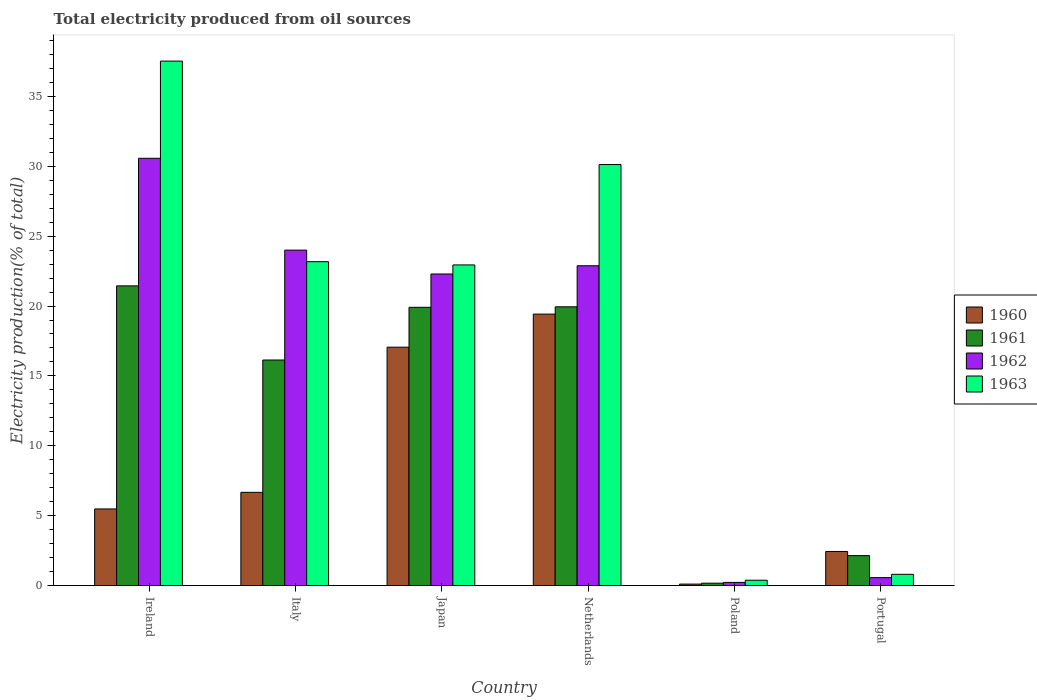Are the number of bars per tick equal to the number of legend labels?
Your response must be concise. Yes. How many bars are there on the 1st tick from the left?
Keep it short and to the point. 4. How many bars are there on the 4th tick from the right?
Ensure brevity in your answer.  4. What is the label of the 4th group of bars from the left?
Give a very brief answer. Netherlands. In how many cases, is the number of bars for a given country not equal to the number of legend labels?
Ensure brevity in your answer.  0. What is the total electricity produced in 1960 in Poland?
Offer a terse response. 0.11. Across all countries, what is the maximum total electricity produced in 1963?
Your response must be concise. 37.53. Across all countries, what is the minimum total electricity produced in 1961?
Make the answer very short. 0.17. In which country was the total electricity produced in 1961 maximum?
Your response must be concise. Ireland. In which country was the total electricity produced in 1963 minimum?
Provide a succinct answer. Poland. What is the total total electricity produced in 1963 in the graph?
Offer a very short reply. 114.95. What is the difference between the total electricity produced in 1963 in Italy and that in Portugal?
Your response must be concise. 22.37. What is the difference between the total electricity produced in 1960 in Ireland and the total electricity produced in 1961 in Italy?
Your response must be concise. -10.66. What is the average total electricity produced in 1961 per country?
Keep it short and to the point. 13.29. What is the difference between the total electricity produced of/in 1960 and total electricity produced of/in 1961 in Japan?
Ensure brevity in your answer.  -2.85. What is the ratio of the total electricity produced in 1961 in Ireland to that in Poland?
Give a very brief answer. 125.7. What is the difference between the highest and the second highest total electricity produced in 1962?
Your answer should be compact. -7.69. What is the difference between the highest and the lowest total electricity produced in 1960?
Offer a terse response. 19.32. Is it the case that in every country, the sum of the total electricity produced in 1962 and total electricity produced in 1960 is greater than the sum of total electricity produced in 1961 and total electricity produced in 1963?
Provide a succinct answer. No. What does the 2nd bar from the left in Poland represents?
Your answer should be very brief. 1961. What does the 1st bar from the right in Japan represents?
Offer a very short reply. 1963. Is it the case that in every country, the sum of the total electricity produced in 1962 and total electricity produced in 1960 is greater than the total electricity produced in 1963?
Keep it short and to the point. No. Are all the bars in the graph horizontal?
Provide a succinct answer. No. How many countries are there in the graph?
Offer a very short reply. 6. Where does the legend appear in the graph?
Offer a terse response. Center right. How are the legend labels stacked?
Your response must be concise. Vertical. What is the title of the graph?
Your response must be concise. Total electricity produced from oil sources. Does "2003" appear as one of the legend labels in the graph?
Ensure brevity in your answer.  No. What is the label or title of the X-axis?
Offer a very short reply. Country. What is the Electricity production(% of total) of 1960 in Ireland?
Make the answer very short. 5.48. What is the Electricity production(% of total) in 1961 in Ireland?
Your answer should be very brief. 21.44. What is the Electricity production(% of total) of 1962 in Ireland?
Provide a short and direct response. 30.57. What is the Electricity production(% of total) of 1963 in Ireland?
Provide a short and direct response. 37.53. What is the Electricity production(% of total) of 1960 in Italy?
Provide a succinct answer. 6.67. What is the Electricity production(% of total) in 1961 in Italy?
Ensure brevity in your answer.  16.14. What is the Electricity production(% of total) in 1962 in Italy?
Provide a succinct answer. 24. What is the Electricity production(% of total) in 1963 in Italy?
Provide a short and direct response. 23.17. What is the Electricity production(% of total) of 1960 in Japan?
Give a very brief answer. 17.06. What is the Electricity production(% of total) of 1961 in Japan?
Offer a terse response. 19.91. What is the Electricity production(% of total) of 1962 in Japan?
Give a very brief answer. 22.29. What is the Electricity production(% of total) in 1963 in Japan?
Offer a terse response. 22.94. What is the Electricity production(% of total) of 1960 in Netherlands?
Provide a short and direct response. 19.42. What is the Electricity production(% of total) of 1961 in Netherlands?
Your answer should be very brief. 19.94. What is the Electricity production(% of total) of 1962 in Netherlands?
Your answer should be very brief. 22.88. What is the Electricity production(% of total) of 1963 in Netherlands?
Provide a succinct answer. 30.12. What is the Electricity production(% of total) of 1960 in Poland?
Offer a terse response. 0.11. What is the Electricity production(% of total) in 1961 in Poland?
Offer a very short reply. 0.17. What is the Electricity production(% of total) in 1962 in Poland?
Your answer should be compact. 0.23. What is the Electricity production(% of total) of 1963 in Poland?
Your answer should be very brief. 0.38. What is the Electricity production(% of total) in 1960 in Portugal?
Give a very brief answer. 2.44. What is the Electricity production(% of total) of 1961 in Portugal?
Provide a succinct answer. 2.14. What is the Electricity production(% of total) of 1962 in Portugal?
Provide a succinct answer. 0.57. What is the Electricity production(% of total) in 1963 in Portugal?
Provide a succinct answer. 0.81. Across all countries, what is the maximum Electricity production(% of total) of 1960?
Ensure brevity in your answer.  19.42. Across all countries, what is the maximum Electricity production(% of total) in 1961?
Ensure brevity in your answer.  21.44. Across all countries, what is the maximum Electricity production(% of total) in 1962?
Give a very brief answer. 30.57. Across all countries, what is the maximum Electricity production(% of total) in 1963?
Offer a very short reply. 37.53. Across all countries, what is the minimum Electricity production(% of total) of 1960?
Make the answer very short. 0.11. Across all countries, what is the minimum Electricity production(% of total) of 1961?
Make the answer very short. 0.17. Across all countries, what is the minimum Electricity production(% of total) of 1962?
Make the answer very short. 0.23. Across all countries, what is the minimum Electricity production(% of total) of 1963?
Provide a short and direct response. 0.38. What is the total Electricity production(% of total) in 1960 in the graph?
Keep it short and to the point. 51.18. What is the total Electricity production(% of total) of 1961 in the graph?
Your response must be concise. 79.75. What is the total Electricity production(% of total) of 1962 in the graph?
Your response must be concise. 100.54. What is the total Electricity production(% of total) of 1963 in the graph?
Your answer should be compact. 114.95. What is the difference between the Electricity production(% of total) of 1960 in Ireland and that in Italy?
Offer a very short reply. -1.19. What is the difference between the Electricity production(% of total) in 1961 in Ireland and that in Italy?
Offer a very short reply. 5.3. What is the difference between the Electricity production(% of total) in 1962 in Ireland and that in Italy?
Give a very brief answer. 6.57. What is the difference between the Electricity production(% of total) in 1963 in Ireland and that in Italy?
Make the answer very short. 14.35. What is the difference between the Electricity production(% of total) in 1960 in Ireland and that in Japan?
Keep it short and to the point. -11.57. What is the difference between the Electricity production(% of total) of 1961 in Ireland and that in Japan?
Keep it short and to the point. 1.53. What is the difference between the Electricity production(% of total) in 1962 in Ireland and that in Japan?
Give a very brief answer. 8.28. What is the difference between the Electricity production(% of total) of 1963 in Ireland and that in Japan?
Your response must be concise. 14.58. What is the difference between the Electricity production(% of total) of 1960 in Ireland and that in Netherlands?
Your answer should be very brief. -13.94. What is the difference between the Electricity production(% of total) in 1961 in Ireland and that in Netherlands?
Give a very brief answer. 1.5. What is the difference between the Electricity production(% of total) of 1962 in Ireland and that in Netherlands?
Offer a very short reply. 7.69. What is the difference between the Electricity production(% of total) of 1963 in Ireland and that in Netherlands?
Your answer should be compact. 7.4. What is the difference between the Electricity production(% of total) in 1960 in Ireland and that in Poland?
Provide a succinct answer. 5.38. What is the difference between the Electricity production(% of total) in 1961 in Ireland and that in Poland?
Offer a terse response. 21.27. What is the difference between the Electricity production(% of total) in 1962 in Ireland and that in Poland?
Keep it short and to the point. 30.34. What is the difference between the Electricity production(% of total) in 1963 in Ireland and that in Poland?
Your response must be concise. 37.14. What is the difference between the Electricity production(% of total) in 1960 in Ireland and that in Portugal?
Offer a very short reply. 3.04. What is the difference between the Electricity production(% of total) of 1961 in Ireland and that in Portugal?
Provide a succinct answer. 19.3. What is the difference between the Electricity production(% of total) in 1962 in Ireland and that in Portugal?
Give a very brief answer. 30. What is the difference between the Electricity production(% of total) in 1963 in Ireland and that in Portugal?
Offer a terse response. 36.72. What is the difference between the Electricity production(% of total) in 1960 in Italy and that in Japan?
Keep it short and to the point. -10.39. What is the difference between the Electricity production(% of total) in 1961 in Italy and that in Japan?
Keep it short and to the point. -3.77. What is the difference between the Electricity production(% of total) of 1962 in Italy and that in Japan?
Give a very brief answer. 1.71. What is the difference between the Electricity production(% of total) of 1963 in Italy and that in Japan?
Give a very brief answer. 0.23. What is the difference between the Electricity production(% of total) of 1960 in Italy and that in Netherlands?
Ensure brevity in your answer.  -12.75. What is the difference between the Electricity production(% of total) in 1961 in Italy and that in Netherlands?
Make the answer very short. -3.81. What is the difference between the Electricity production(% of total) of 1962 in Italy and that in Netherlands?
Offer a very short reply. 1.12. What is the difference between the Electricity production(% of total) of 1963 in Italy and that in Netherlands?
Your answer should be compact. -6.95. What is the difference between the Electricity production(% of total) in 1960 in Italy and that in Poland?
Provide a succinct answer. 6.57. What is the difference between the Electricity production(% of total) in 1961 in Italy and that in Poland?
Make the answer very short. 15.97. What is the difference between the Electricity production(% of total) of 1962 in Italy and that in Poland?
Your answer should be compact. 23.77. What is the difference between the Electricity production(% of total) in 1963 in Italy and that in Poland?
Your answer should be compact. 22.79. What is the difference between the Electricity production(% of total) of 1960 in Italy and that in Portugal?
Make the answer very short. 4.23. What is the difference between the Electricity production(% of total) of 1961 in Italy and that in Portugal?
Ensure brevity in your answer.  14. What is the difference between the Electricity production(% of total) in 1962 in Italy and that in Portugal?
Provide a succinct answer. 23.43. What is the difference between the Electricity production(% of total) in 1963 in Italy and that in Portugal?
Give a very brief answer. 22.37. What is the difference between the Electricity production(% of total) in 1960 in Japan and that in Netherlands?
Your response must be concise. -2.37. What is the difference between the Electricity production(% of total) in 1961 in Japan and that in Netherlands?
Offer a terse response. -0.04. What is the difference between the Electricity production(% of total) of 1962 in Japan and that in Netherlands?
Your answer should be compact. -0.59. What is the difference between the Electricity production(% of total) of 1963 in Japan and that in Netherlands?
Offer a terse response. -7.18. What is the difference between the Electricity production(% of total) of 1960 in Japan and that in Poland?
Ensure brevity in your answer.  16.95. What is the difference between the Electricity production(% of total) in 1961 in Japan and that in Poland?
Make the answer very short. 19.74. What is the difference between the Electricity production(% of total) in 1962 in Japan and that in Poland?
Your answer should be very brief. 22.07. What is the difference between the Electricity production(% of total) of 1963 in Japan and that in Poland?
Keep it short and to the point. 22.56. What is the difference between the Electricity production(% of total) in 1960 in Japan and that in Portugal?
Provide a short and direct response. 14.62. What is the difference between the Electricity production(% of total) in 1961 in Japan and that in Portugal?
Your response must be concise. 17.77. What is the difference between the Electricity production(% of total) of 1962 in Japan and that in Portugal?
Your response must be concise. 21.73. What is the difference between the Electricity production(% of total) in 1963 in Japan and that in Portugal?
Give a very brief answer. 22.14. What is the difference between the Electricity production(% of total) in 1960 in Netherlands and that in Poland?
Your answer should be very brief. 19.32. What is the difference between the Electricity production(% of total) in 1961 in Netherlands and that in Poland?
Provide a succinct answer. 19.77. What is the difference between the Electricity production(% of total) of 1962 in Netherlands and that in Poland?
Your answer should be very brief. 22.66. What is the difference between the Electricity production(% of total) of 1963 in Netherlands and that in Poland?
Ensure brevity in your answer.  29.74. What is the difference between the Electricity production(% of total) of 1960 in Netherlands and that in Portugal?
Provide a succinct answer. 16.98. What is the difference between the Electricity production(% of total) of 1961 in Netherlands and that in Portugal?
Make the answer very short. 17.8. What is the difference between the Electricity production(% of total) of 1962 in Netherlands and that in Portugal?
Your response must be concise. 22.31. What is the difference between the Electricity production(% of total) in 1963 in Netherlands and that in Portugal?
Provide a short and direct response. 29.32. What is the difference between the Electricity production(% of total) of 1960 in Poland and that in Portugal?
Keep it short and to the point. -2.33. What is the difference between the Electricity production(% of total) of 1961 in Poland and that in Portugal?
Keep it short and to the point. -1.97. What is the difference between the Electricity production(% of total) in 1962 in Poland and that in Portugal?
Your answer should be compact. -0.34. What is the difference between the Electricity production(% of total) in 1963 in Poland and that in Portugal?
Your response must be concise. -0.42. What is the difference between the Electricity production(% of total) in 1960 in Ireland and the Electricity production(% of total) in 1961 in Italy?
Give a very brief answer. -10.66. What is the difference between the Electricity production(% of total) in 1960 in Ireland and the Electricity production(% of total) in 1962 in Italy?
Make the answer very short. -18.52. What is the difference between the Electricity production(% of total) in 1960 in Ireland and the Electricity production(% of total) in 1963 in Italy?
Provide a succinct answer. -17.69. What is the difference between the Electricity production(% of total) in 1961 in Ireland and the Electricity production(% of total) in 1962 in Italy?
Make the answer very short. -2.56. What is the difference between the Electricity production(% of total) in 1961 in Ireland and the Electricity production(% of total) in 1963 in Italy?
Your response must be concise. -1.73. What is the difference between the Electricity production(% of total) in 1962 in Ireland and the Electricity production(% of total) in 1963 in Italy?
Offer a terse response. 7.4. What is the difference between the Electricity production(% of total) of 1960 in Ireland and the Electricity production(% of total) of 1961 in Japan?
Provide a short and direct response. -14.43. What is the difference between the Electricity production(% of total) in 1960 in Ireland and the Electricity production(% of total) in 1962 in Japan?
Provide a succinct answer. -16.81. What is the difference between the Electricity production(% of total) of 1960 in Ireland and the Electricity production(% of total) of 1963 in Japan?
Make the answer very short. -17.46. What is the difference between the Electricity production(% of total) in 1961 in Ireland and the Electricity production(% of total) in 1962 in Japan?
Keep it short and to the point. -0.85. What is the difference between the Electricity production(% of total) in 1961 in Ireland and the Electricity production(% of total) in 1963 in Japan?
Your response must be concise. -1.5. What is the difference between the Electricity production(% of total) of 1962 in Ireland and the Electricity production(% of total) of 1963 in Japan?
Your response must be concise. 7.63. What is the difference between the Electricity production(% of total) in 1960 in Ireland and the Electricity production(% of total) in 1961 in Netherlands?
Offer a very short reply. -14.46. What is the difference between the Electricity production(% of total) in 1960 in Ireland and the Electricity production(% of total) in 1962 in Netherlands?
Your answer should be compact. -17.4. What is the difference between the Electricity production(% of total) of 1960 in Ireland and the Electricity production(% of total) of 1963 in Netherlands?
Your response must be concise. -24.64. What is the difference between the Electricity production(% of total) of 1961 in Ireland and the Electricity production(% of total) of 1962 in Netherlands?
Ensure brevity in your answer.  -1.44. What is the difference between the Electricity production(% of total) of 1961 in Ireland and the Electricity production(% of total) of 1963 in Netherlands?
Your response must be concise. -8.68. What is the difference between the Electricity production(% of total) of 1962 in Ireland and the Electricity production(% of total) of 1963 in Netherlands?
Provide a short and direct response. 0.45. What is the difference between the Electricity production(% of total) in 1960 in Ireland and the Electricity production(% of total) in 1961 in Poland?
Ensure brevity in your answer.  5.31. What is the difference between the Electricity production(% of total) in 1960 in Ireland and the Electricity production(% of total) in 1962 in Poland?
Make the answer very short. 5.26. What is the difference between the Electricity production(% of total) of 1960 in Ireland and the Electricity production(% of total) of 1963 in Poland?
Offer a very short reply. 5.1. What is the difference between the Electricity production(% of total) in 1961 in Ireland and the Electricity production(% of total) in 1962 in Poland?
Provide a short and direct response. 21.22. What is the difference between the Electricity production(% of total) in 1961 in Ireland and the Electricity production(% of total) in 1963 in Poland?
Offer a terse response. 21.06. What is the difference between the Electricity production(% of total) of 1962 in Ireland and the Electricity production(% of total) of 1963 in Poland?
Keep it short and to the point. 30.19. What is the difference between the Electricity production(% of total) in 1960 in Ireland and the Electricity production(% of total) in 1961 in Portugal?
Make the answer very short. 3.34. What is the difference between the Electricity production(% of total) in 1960 in Ireland and the Electricity production(% of total) in 1962 in Portugal?
Your response must be concise. 4.91. What is the difference between the Electricity production(% of total) in 1960 in Ireland and the Electricity production(% of total) in 1963 in Portugal?
Provide a succinct answer. 4.68. What is the difference between the Electricity production(% of total) of 1961 in Ireland and the Electricity production(% of total) of 1962 in Portugal?
Offer a very short reply. 20.87. What is the difference between the Electricity production(% of total) in 1961 in Ireland and the Electricity production(% of total) in 1963 in Portugal?
Give a very brief answer. 20.64. What is the difference between the Electricity production(% of total) in 1962 in Ireland and the Electricity production(% of total) in 1963 in Portugal?
Ensure brevity in your answer.  29.77. What is the difference between the Electricity production(% of total) of 1960 in Italy and the Electricity production(% of total) of 1961 in Japan?
Your response must be concise. -13.24. What is the difference between the Electricity production(% of total) in 1960 in Italy and the Electricity production(% of total) in 1962 in Japan?
Ensure brevity in your answer.  -15.62. What is the difference between the Electricity production(% of total) in 1960 in Italy and the Electricity production(% of total) in 1963 in Japan?
Provide a succinct answer. -16.27. What is the difference between the Electricity production(% of total) of 1961 in Italy and the Electricity production(% of total) of 1962 in Japan?
Ensure brevity in your answer.  -6.15. What is the difference between the Electricity production(% of total) in 1961 in Italy and the Electricity production(% of total) in 1963 in Japan?
Offer a terse response. -6.8. What is the difference between the Electricity production(% of total) of 1962 in Italy and the Electricity production(% of total) of 1963 in Japan?
Your answer should be compact. 1.06. What is the difference between the Electricity production(% of total) of 1960 in Italy and the Electricity production(% of total) of 1961 in Netherlands?
Offer a very short reply. -13.27. What is the difference between the Electricity production(% of total) in 1960 in Italy and the Electricity production(% of total) in 1962 in Netherlands?
Your answer should be compact. -16.21. What is the difference between the Electricity production(% of total) in 1960 in Italy and the Electricity production(% of total) in 1963 in Netherlands?
Give a very brief answer. -23.45. What is the difference between the Electricity production(% of total) in 1961 in Italy and the Electricity production(% of total) in 1962 in Netherlands?
Make the answer very short. -6.74. What is the difference between the Electricity production(% of total) of 1961 in Italy and the Electricity production(% of total) of 1963 in Netherlands?
Keep it short and to the point. -13.98. What is the difference between the Electricity production(% of total) of 1962 in Italy and the Electricity production(% of total) of 1963 in Netherlands?
Give a very brief answer. -6.12. What is the difference between the Electricity production(% of total) in 1960 in Italy and the Electricity production(% of total) in 1961 in Poland?
Offer a very short reply. 6.5. What is the difference between the Electricity production(% of total) of 1960 in Italy and the Electricity production(% of total) of 1962 in Poland?
Your answer should be compact. 6.44. What is the difference between the Electricity production(% of total) in 1960 in Italy and the Electricity production(% of total) in 1963 in Poland?
Your answer should be very brief. 6.29. What is the difference between the Electricity production(% of total) of 1961 in Italy and the Electricity production(% of total) of 1962 in Poland?
Your answer should be compact. 15.91. What is the difference between the Electricity production(% of total) of 1961 in Italy and the Electricity production(% of total) of 1963 in Poland?
Provide a short and direct response. 15.76. What is the difference between the Electricity production(% of total) of 1962 in Italy and the Electricity production(% of total) of 1963 in Poland?
Keep it short and to the point. 23.62. What is the difference between the Electricity production(% of total) of 1960 in Italy and the Electricity production(% of total) of 1961 in Portugal?
Your answer should be very brief. 4.53. What is the difference between the Electricity production(% of total) of 1960 in Italy and the Electricity production(% of total) of 1962 in Portugal?
Make the answer very short. 6.1. What is the difference between the Electricity production(% of total) in 1960 in Italy and the Electricity production(% of total) in 1963 in Portugal?
Your answer should be very brief. 5.87. What is the difference between the Electricity production(% of total) in 1961 in Italy and the Electricity production(% of total) in 1962 in Portugal?
Provide a succinct answer. 15.57. What is the difference between the Electricity production(% of total) of 1961 in Italy and the Electricity production(% of total) of 1963 in Portugal?
Keep it short and to the point. 15.33. What is the difference between the Electricity production(% of total) in 1962 in Italy and the Electricity production(% of total) in 1963 in Portugal?
Offer a terse response. 23.19. What is the difference between the Electricity production(% of total) of 1960 in Japan and the Electricity production(% of total) of 1961 in Netherlands?
Provide a short and direct response. -2.89. What is the difference between the Electricity production(% of total) of 1960 in Japan and the Electricity production(% of total) of 1962 in Netherlands?
Give a very brief answer. -5.83. What is the difference between the Electricity production(% of total) in 1960 in Japan and the Electricity production(% of total) in 1963 in Netherlands?
Keep it short and to the point. -13.07. What is the difference between the Electricity production(% of total) of 1961 in Japan and the Electricity production(% of total) of 1962 in Netherlands?
Your response must be concise. -2.97. What is the difference between the Electricity production(% of total) in 1961 in Japan and the Electricity production(% of total) in 1963 in Netherlands?
Provide a succinct answer. -10.21. What is the difference between the Electricity production(% of total) of 1962 in Japan and the Electricity production(% of total) of 1963 in Netherlands?
Keep it short and to the point. -7.83. What is the difference between the Electricity production(% of total) of 1960 in Japan and the Electricity production(% of total) of 1961 in Poland?
Keep it short and to the point. 16.89. What is the difference between the Electricity production(% of total) of 1960 in Japan and the Electricity production(% of total) of 1962 in Poland?
Offer a terse response. 16.83. What is the difference between the Electricity production(% of total) of 1960 in Japan and the Electricity production(% of total) of 1963 in Poland?
Provide a succinct answer. 16.67. What is the difference between the Electricity production(% of total) in 1961 in Japan and the Electricity production(% of total) in 1962 in Poland?
Provide a short and direct response. 19.68. What is the difference between the Electricity production(% of total) in 1961 in Japan and the Electricity production(% of total) in 1963 in Poland?
Your response must be concise. 19.53. What is the difference between the Electricity production(% of total) in 1962 in Japan and the Electricity production(% of total) in 1963 in Poland?
Offer a terse response. 21.91. What is the difference between the Electricity production(% of total) of 1960 in Japan and the Electricity production(% of total) of 1961 in Portugal?
Your response must be concise. 14.91. What is the difference between the Electricity production(% of total) in 1960 in Japan and the Electricity production(% of total) in 1962 in Portugal?
Give a very brief answer. 16.49. What is the difference between the Electricity production(% of total) of 1960 in Japan and the Electricity production(% of total) of 1963 in Portugal?
Offer a very short reply. 16.25. What is the difference between the Electricity production(% of total) of 1961 in Japan and the Electricity production(% of total) of 1962 in Portugal?
Keep it short and to the point. 19.34. What is the difference between the Electricity production(% of total) of 1961 in Japan and the Electricity production(% of total) of 1963 in Portugal?
Make the answer very short. 19.1. What is the difference between the Electricity production(% of total) in 1962 in Japan and the Electricity production(% of total) in 1963 in Portugal?
Keep it short and to the point. 21.49. What is the difference between the Electricity production(% of total) in 1960 in Netherlands and the Electricity production(% of total) in 1961 in Poland?
Keep it short and to the point. 19.25. What is the difference between the Electricity production(% of total) in 1960 in Netherlands and the Electricity production(% of total) in 1962 in Poland?
Keep it short and to the point. 19.2. What is the difference between the Electricity production(% of total) in 1960 in Netherlands and the Electricity production(% of total) in 1963 in Poland?
Provide a short and direct response. 19.04. What is the difference between the Electricity production(% of total) of 1961 in Netherlands and the Electricity production(% of total) of 1962 in Poland?
Your answer should be very brief. 19.72. What is the difference between the Electricity production(% of total) of 1961 in Netherlands and the Electricity production(% of total) of 1963 in Poland?
Give a very brief answer. 19.56. What is the difference between the Electricity production(% of total) of 1962 in Netherlands and the Electricity production(% of total) of 1963 in Poland?
Offer a very short reply. 22.5. What is the difference between the Electricity production(% of total) in 1960 in Netherlands and the Electricity production(% of total) in 1961 in Portugal?
Keep it short and to the point. 17.28. What is the difference between the Electricity production(% of total) of 1960 in Netherlands and the Electricity production(% of total) of 1962 in Portugal?
Keep it short and to the point. 18.86. What is the difference between the Electricity production(% of total) in 1960 in Netherlands and the Electricity production(% of total) in 1963 in Portugal?
Offer a very short reply. 18.62. What is the difference between the Electricity production(% of total) in 1961 in Netherlands and the Electricity production(% of total) in 1962 in Portugal?
Keep it short and to the point. 19.38. What is the difference between the Electricity production(% of total) of 1961 in Netherlands and the Electricity production(% of total) of 1963 in Portugal?
Keep it short and to the point. 19.14. What is the difference between the Electricity production(% of total) in 1962 in Netherlands and the Electricity production(% of total) in 1963 in Portugal?
Your answer should be compact. 22.08. What is the difference between the Electricity production(% of total) of 1960 in Poland and the Electricity production(% of total) of 1961 in Portugal?
Your answer should be compact. -2.04. What is the difference between the Electricity production(% of total) of 1960 in Poland and the Electricity production(% of total) of 1962 in Portugal?
Your response must be concise. -0.46. What is the difference between the Electricity production(% of total) of 1960 in Poland and the Electricity production(% of total) of 1963 in Portugal?
Provide a succinct answer. -0.7. What is the difference between the Electricity production(% of total) in 1961 in Poland and the Electricity production(% of total) in 1962 in Portugal?
Provide a short and direct response. -0.4. What is the difference between the Electricity production(% of total) in 1961 in Poland and the Electricity production(% of total) in 1963 in Portugal?
Ensure brevity in your answer.  -0.63. What is the difference between the Electricity production(% of total) of 1962 in Poland and the Electricity production(% of total) of 1963 in Portugal?
Offer a very short reply. -0.58. What is the average Electricity production(% of total) in 1960 per country?
Your response must be concise. 8.53. What is the average Electricity production(% of total) in 1961 per country?
Offer a very short reply. 13.29. What is the average Electricity production(% of total) of 1962 per country?
Offer a very short reply. 16.76. What is the average Electricity production(% of total) in 1963 per country?
Offer a very short reply. 19.16. What is the difference between the Electricity production(% of total) in 1960 and Electricity production(% of total) in 1961 in Ireland?
Make the answer very short. -15.96. What is the difference between the Electricity production(% of total) of 1960 and Electricity production(% of total) of 1962 in Ireland?
Ensure brevity in your answer.  -25.09. What is the difference between the Electricity production(% of total) of 1960 and Electricity production(% of total) of 1963 in Ireland?
Ensure brevity in your answer.  -32.04. What is the difference between the Electricity production(% of total) in 1961 and Electricity production(% of total) in 1962 in Ireland?
Ensure brevity in your answer.  -9.13. What is the difference between the Electricity production(% of total) of 1961 and Electricity production(% of total) of 1963 in Ireland?
Offer a terse response. -16.08. What is the difference between the Electricity production(% of total) of 1962 and Electricity production(% of total) of 1963 in Ireland?
Your answer should be very brief. -6.95. What is the difference between the Electricity production(% of total) in 1960 and Electricity production(% of total) in 1961 in Italy?
Your answer should be very brief. -9.47. What is the difference between the Electricity production(% of total) of 1960 and Electricity production(% of total) of 1962 in Italy?
Ensure brevity in your answer.  -17.33. What is the difference between the Electricity production(% of total) in 1960 and Electricity production(% of total) in 1963 in Italy?
Provide a short and direct response. -16.5. What is the difference between the Electricity production(% of total) in 1961 and Electricity production(% of total) in 1962 in Italy?
Your answer should be compact. -7.86. What is the difference between the Electricity production(% of total) of 1961 and Electricity production(% of total) of 1963 in Italy?
Offer a very short reply. -7.04. What is the difference between the Electricity production(% of total) of 1962 and Electricity production(% of total) of 1963 in Italy?
Your response must be concise. 0.83. What is the difference between the Electricity production(% of total) of 1960 and Electricity production(% of total) of 1961 in Japan?
Offer a very short reply. -2.85. What is the difference between the Electricity production(% of total) of 1960 and Electricity production(% of total) of 1962 in Japan?
Your response must be concise. -5.24. What is the difference between the Electricity production(% of total) of 1960 and Electricity production(% of total) of 1963 in Japan?
Give a very brief answer. -5.89. What is the difference between the Electricity production(% of total) in 1961 and Electricity production(% of total) in 1962 in Japan?
Keep it short and to the point. -2.38. What is the difference between the Electricity production(% of total) of 1961 and Electricity production(% of total) of 1963 in Japan?
Offer a terse response. -3.03. What is the difference between the Electricity production(% of total) of 1962 and Electricity production(% of total) of 1963 in Japan?
Offer a very short reply. -0.65. What is the difference between the Electricity production(% of total) of 1960 and Electricity production(% of total) of 1961 in Netherlands?
Keep it short and to the point. -0.52. What is the difference between the Electricity production(% of total) in 1960 and Electricity production(% of total) in 1962 in Netherlands?
Your answer should be very brief. -3.46. What is the difference between the Electricity production(% of total) of 1960 and Electricity production(% of total) of 1963 in Netherlands?
Provide a short and direct response. -10.7. What is the difference between the Electricity production(% of total) of 1961 and Electricity production(% of total) of 1962 in Netherlands?
Your answer should be compact. -2.94. What is the difference between the Electricity production(% of total) of 1961 and Electricity production(% of total) of 1963 in Netherlands?
Your response must be concise. -10.18. What is the difference between the Electricity production(% of total) of 1962 and Electricity production(% of total) of 1963 in Netherlands?
Your response must be concise. -7.24. What is the difference between the Electricity production(% of total) in 1960 and Electricity production(% of total) in 1961 in Poland?
Make the answer very short. -0.06. What is the difference between the Electricity production(% of total) in 1960 and Electricity production(% of total) in 1962 in Poland?
Provide a succinct answer. -0.12. What is the difference between the Electricity production(% of total) of 1960 and Electricity production(% of total) of 1963 in Poland?
Offer a very short reply. -0.28. What is the difference between the Electricity production(% of total) of 1961 and Electricity production(% of total) of 1962 in Poland?
Ensure brevity in your answer.  -0.06. What is the difference between the Electricity production(% of total) of 1961 and Electricity production(% of total) of 1963 in Poland?
Your response must be concise. -0.21. What is the difference between the Electricity production(% of total) in 1962 and Electricity production(% of total) in 1963 in Poland?
Offer a terse response. -0.16. What is the difference between the Electricity production(% of total) of 1960 and Electricity production(% of total) of 1961 in Portugal?
Give a very brief answer. 0.3. What is the difference between the Electricity production(% of total) in 1960 and Electricity production(% of total) in 1962 in Portugal?
Your response must be concise. 1.87. What is the difference between the Electricity production(% of total) of 1960 and Electricity production(% of total) of 1963 in Portugal?
Give a very brief answer. 1.63. What is the difference between the Electricity production(% of total) in 1961 and Electricity production(% of total) in 1962 in Portugal?
Your answer should be compact. 1.57. What is the difference between the Electricity production(% of total) of 1961 and Electricity production(% of total) of 1963 in Portugal?
Offer a terse response. 1.34. What is the difference between the Electricity production(% of total) in 1962 and Electricity production(% of total) in 1963 in Portugal?
Offer a terse response. -0.24. What is the ratio of the Electricity production(% of total) of 1960 in Ireland to that in Italy?
Make the answer very short. 0.82. What is the ratio of the Electricity production(% of total) in 1961 in Ireland to that in Italy?
Give a very brief answer. 1.33. What is the ratio of the Electricity production(% of total) in 1962 in Ireland to that in Italy?
Provide a short and direct response. 1.27. What is the ratio of the Electricity production(% of total) in 1963 in Ireland to that in Italy?
Keep it short and to the point. 1.62. What is the ratio of the Electricity production(% of total) in 1960 in Ireland to that in Japan?
Your answer should be compact. 0.32. What is the ratio of the Electricity production(% of total) in 1961 in Ireland to that in Japan?
Give a very brief answer. 1.08. What is the ratio of the Electricity production(% of total) in 1962 in Ireland to that in Japan?
Give a very brief answer. 1.37. What is the ratio of the Electricity production(% of total) of 1963 in Ireland to that in Japan?
Your answer should be compact. 1.64. What is the ratio of the Electricity production(% of total) in 1960 in Ireland to that in Netherlands?
Offer a very short reply. 0.28. What is the ratio of the Electricity production(% of total) in 1961 in Ireland to that in Netherlands?
Your response must be concise. 1.08. What is the ratio of the Electricity production(% of total) in 1962 in Ireland to that in Netherlands?
Your answer should be compact. 1.34. What is the ratio of the Electricity production(% of total) in 1963 in Ireland to that in Netherlands?
Provide a succinct answer. 1.25. What is the ratio of the Electricity production(% of total) in 1960 in Ireland to that in Poland?
Offer a very short reply. 51.78. What is the ratio of the Electricity production(% of total) in 1961 in Ireland to that in Poland?
Give a very brief answer. 125.7. What is the ratio of the Electricity production(% of total) of 1962 in Ireland to that in Poland?
Provide a short and direct response. 135.14. What is the ratio of the Electricity production(% of total) in 1963 in Ireland to that in Poland?
Provide a short and direct response. 98.31. What is the ratio of the Electricity production(% of total) in 1960 in Ireland to that in Portugal?
Your answer should be compact. 2.25. What is the ratio of the Electricity production(% of total) of 1961 in Ireland to that in Portugal?
Your answer should be very brief. 10.01. What is the ratio of the Electricity production(% of total) in 1962 in Ireland to that in Portugal?
Make the answer very short. 53.8. What is the ratio of the Electricity production(% of total) of 1963 in Ireland to that in Portugal?
Make the answer very short. 46.6. What is the ratio of the Electricity production(% of total) in 1960 in Italy to that in Japan?
Offer a terse response. 0.39. What is the ratio of the Electricity production(% of total) of 1961 in Italy to that in Japan?
Provide a succinct answer. 0.81. What is the ratio of the Electricity production(% of total) in 1962 in Italy to that in Japan?
Give a very brief answer. 1.08. What is the ratio of the Electricity production(% of total) in 1960 in Italy to that in Netherlands?
Give a very brief answer. 0.34. What is the ratio of the Electricity production(% of total) of 1961 in Italy to that in Netherlands?
Offer a terse response. 0.81. What is the ratio of the Electricity production(% of total) of 1962 in Italy to that in Netherlands?
Keep it short and to the point. 1.05. What is the ratio of the Electricity production(% of total) in 1963 in Italy to that in Netherlands?
Your answer should be very brief. 0.77. What is the ratio of the Electricity production(% of total) in 1960 in Italy to that in Poland?
Make the answer very short. 63.01. What is the ratio of the Electricity production(% of total) in 1961 in Italy to that in Poland?
Your response must be concise. 94.6. What is the ratio of the Electricity production(% of total) of 1962 in Italy to that in Poland?
Give a very brief answer. 106.09. What is the ratio of the Electricity production(% of total) of 1963 in Italy to that in Poland?
Provide a succinct answer. 60.72. What is the ratio of the Electricity production(% of total) of 1960 in Italy to that in Portugal?
Your answer should be very brief. 2.73. What is the ratio of the Electricity production(% of total) of 1961 in Italy to that in Portugal?
Offer a terse response. 7.54. What is the ratio of the Electricity production(% of total) in 1962 in Italy to that in Portugal?
Your response must be concise. 42.24. What is the ratio of the Electricity production(% of total) of 1963 in Italy to that in Portugal?
Offer a terse response. 28.78. What is the ratio of the Electricity production(% of total) of 1960 in Japan to that in Netherlands?
Keep it short and to the point. 0.88. What is the ratio of the Electricity production(% of total) in 1962 in Japan to that in Netherlands?
Your answer should be compact. 0.97. What is the ratio of the Electricity production(% of total) in 1963 in Japan to that in Netherlands?
Ensure brevity in your answer.  0.76. What is the ratio of the Electricity production(% of total) in 1960 in Japan to that in Poland?
Make the answer very short. 161.11. What is the ratio of the Electricity production(% of total) in 1961 in Japan to that in Poland?
Offer a terse response. 116.7. What is the ratio of the Electricity production(% of total) in 1962 in Japan to that in Poland?
Keep it short and to the point. 98.55. What is the ratio of the Electricity production(% of total) in 1963 in Japan to that in Poland?
Ensure brevity in your answer.  60.11. What is the ratio of the Electricity production(% of total) of 1960 in Japan to that in Portugal?
Ensure brevity in your answer.  6.99. What is the ratio of the Electricity production(% of total) of 1961 in Japan to that in Portugal?
Provide a short and direct response. 9.3. What is the ratio of the Electricity production(% of total) in 1962 in Japan to that in Portugal?
Provide a succinct answer. 39.24. What is the ratio of the Electricity production(% of total) of 1963 in Japan to that in Portugal?
Your answer should be compact. 28.49. What is the ratio of the Electricity production(% of total) of 1960 in Netherlands to that in Poland?
Give a very brief answer. 183.47. What is the ratio of the Electricity production(% of total) of 1961 in Netherlands to that in Poland?
Give a very brief answer. 116.91. What is the ratio of the Electricity production(% of total) in 1962 in Netherlands to that in Poland?
Offer a very short reply. 101.15. What is the ratio of the Electricity production(% of total) in 1963 in Netherlands to that in Poland?
Offer a terse response. 78.92. What is the ratio of the Electricity production(% of total) of 1960 in Netherlands to that in Portugal?
Give a very brief answer. 7.96. What is the ratio of the Electricity production(% of total) in 1961 in Netherlands to that in Portugal?
Your answer should be very brief. 9.31. What is the ratio of the Electricity production(% of total) in 1962 in Netherlands to that in Portugal?
Give a very brief answer. 40.27. What is the ratio of the Electricity production(% of total) of 1963 in Netherlands to that in Portugal?
Your answer should be compact. 37.4. What is the ratio of the Electricity production(% of total) in 1960 in Poland to that in Portugal?
Ensure brevity in your answer.  0.04. What is the ratio of the Electricity production(% of total) in 1961 in Poland to that in Portugal?
Offer a very short reply. 0.08. What is the ratio of the Electricity production(% of total) in 1962 in Poland to that in Portugal?
Ensure brevity in your answer.  0.4. What is the ratio of the Electricity production(% of total) in 1963 in Poland to that in Portugal?
Provide a succinct answer. 0.47. What is the difference between the highest and the second highest Electricity production(% of total) of 1960?
Give a very brief answer. 2.37. What is the difference between the highest and the second highest Electricity production(% of total) in 1961?
Your response must be concise. 1.5. What is the difference between the highest and the second highest Electricity production(% of total) of 1962?
Your answer should be compact. 6.57. What is the difference between the highest and the second highest Electricity production(% of total) in 1963?
Your answer should be compact. 7.4. What is the difference between the highest and the lowest Electricity production(% of total) in 1960?
Provide a short and direct response. 19.32. What is the difference between the highest and the lowest Electricity production(% of total) in 1961?
Your answer should be very brief. 21.27. What is the difference between the highest and the lowest Electricity production(% of total) in 1962?
Offer a terse response. 30.34. What is the difference between the highest and the lowest Electricity production(% of total) in 1963?
Offer a very short reply. 37.14. 